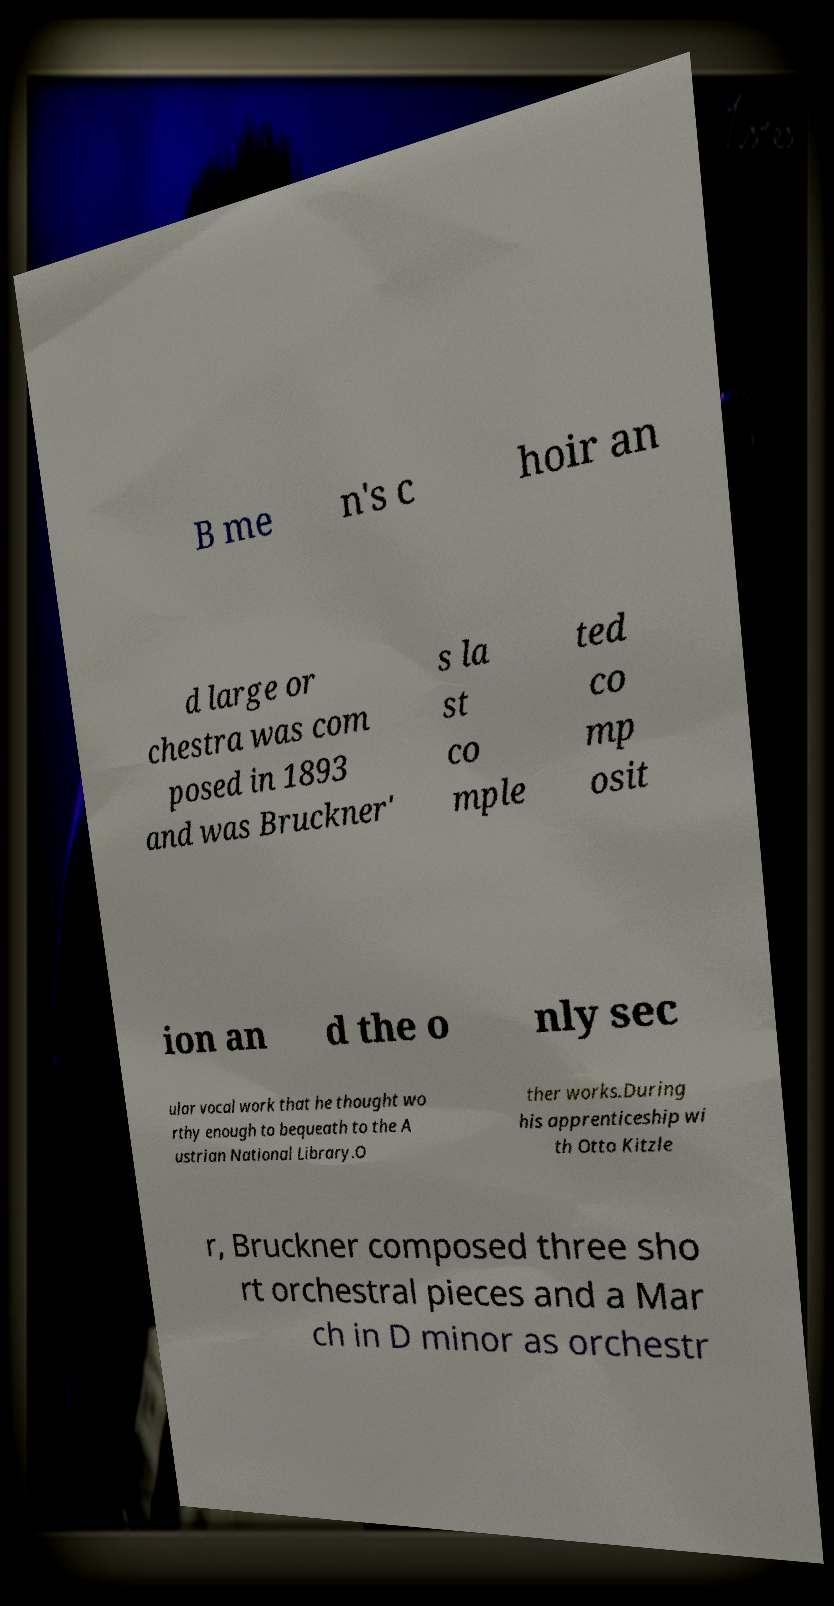Can you accurately transcribe the text from the provided image for me? B me n's c hoir an d large or chestra was com posed in 1893 and was Bruckner' s la st co mple ted co mp osit ion an d the o nly sec ular vocal work that he thought wo rthy enough to bequeath to the A ustrian National Library.O ther works.During his apprenticeship wi th Otto Kitzle r, Bruckner composed three sho rt orchestral pieces and a Mar ch in D minor as orchestr 